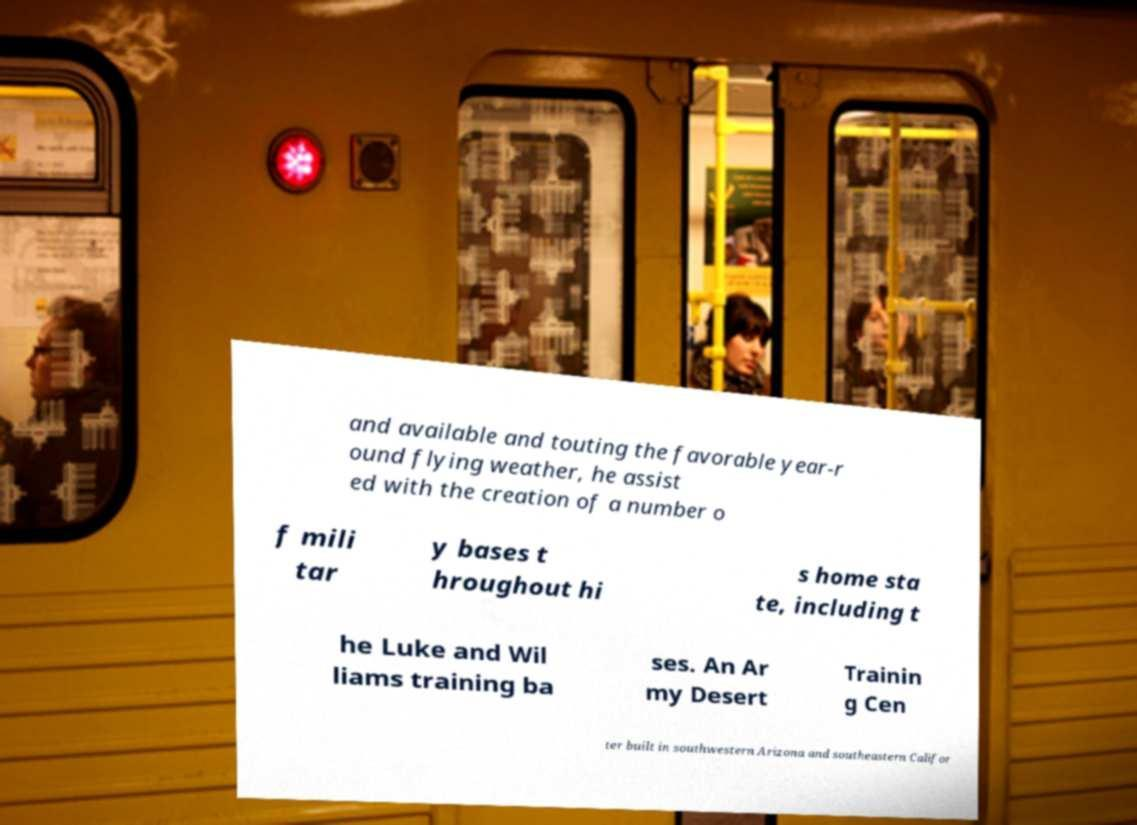Can you accurately transcribe the text from the provided image for me? and available and touting the favorable year-r ound flying weather, he assist ed with the creation of a number o f mili tar y bases t hroughout hi s home sta te, including t he Luke and Wil liams training ba ses. An Ar my Desert Trainin g Cen ter built in southwestern Arizona and southeastern Califor 